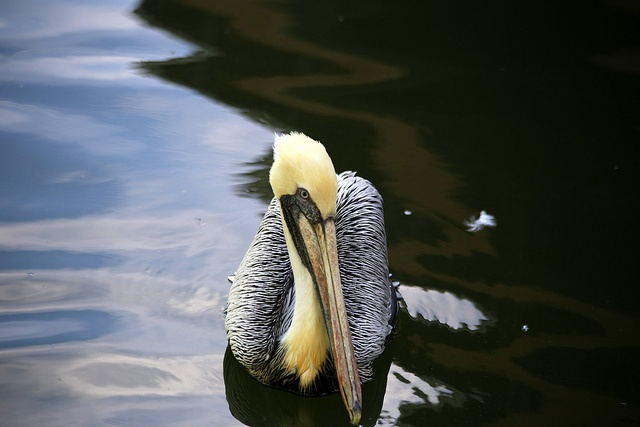Describe the objects in this image and their specific colors. I can see a bird in gray, black, ivory, and darkgray tones in this image. 